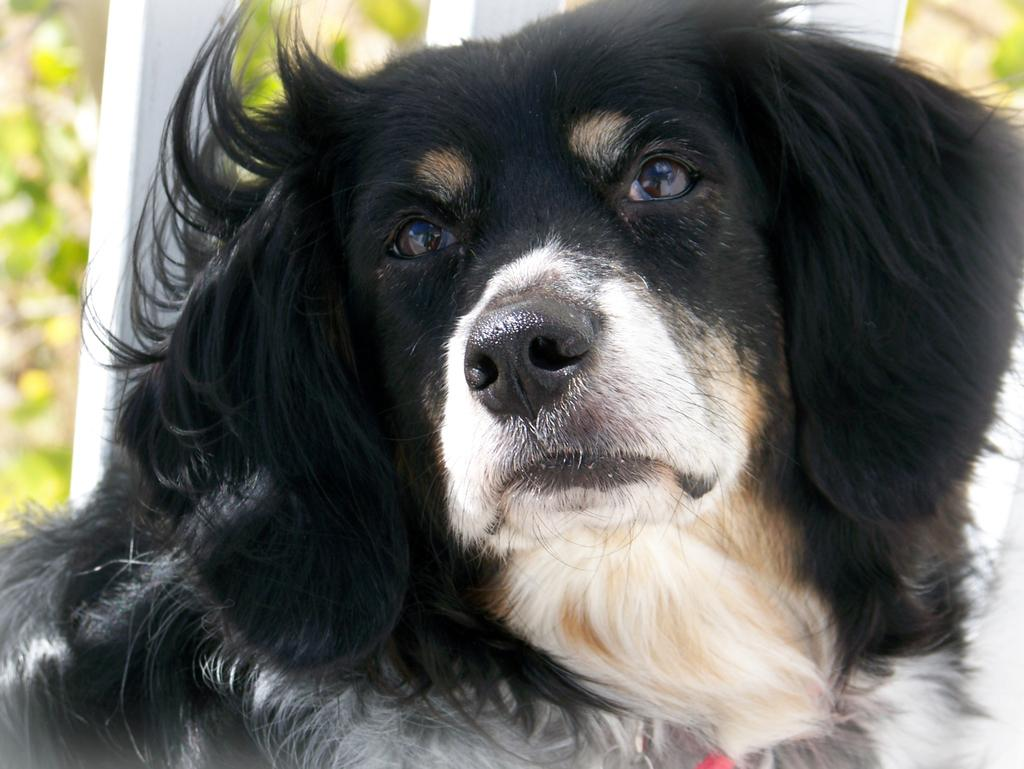What type of animal is in the image? There is a dog in the image. Can you describe the dog's appearance? The dog has a mix of white, cream, black, and brown colors. What can be seen in the background of the image? There are trees and a white-colored object in the background of the image. What type of cave can be seen in the background of the image? There is no cave present in the image; only trees and a white-colored object are visible in the background. What type of eggnog is the dog drinking in the image? There is no eggnog present in the image; the dog is not depicted with any food or drink. 